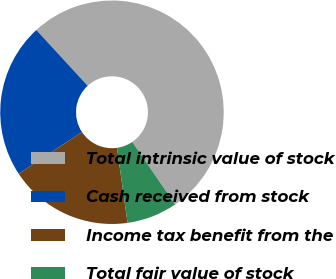Convert chart. <chart><loc_0><loc_0><loc_500><loc_500><pie_chart><fcel>Total intrinsic value of stock<fcel>Cash received from stock<fcel>Income tax benefit from the<fcel>Total fair value of stock<nl><fcel>52.28%<fcel>22.44%<fcel>17.95%<fcel>7.33%<nl></chart> 